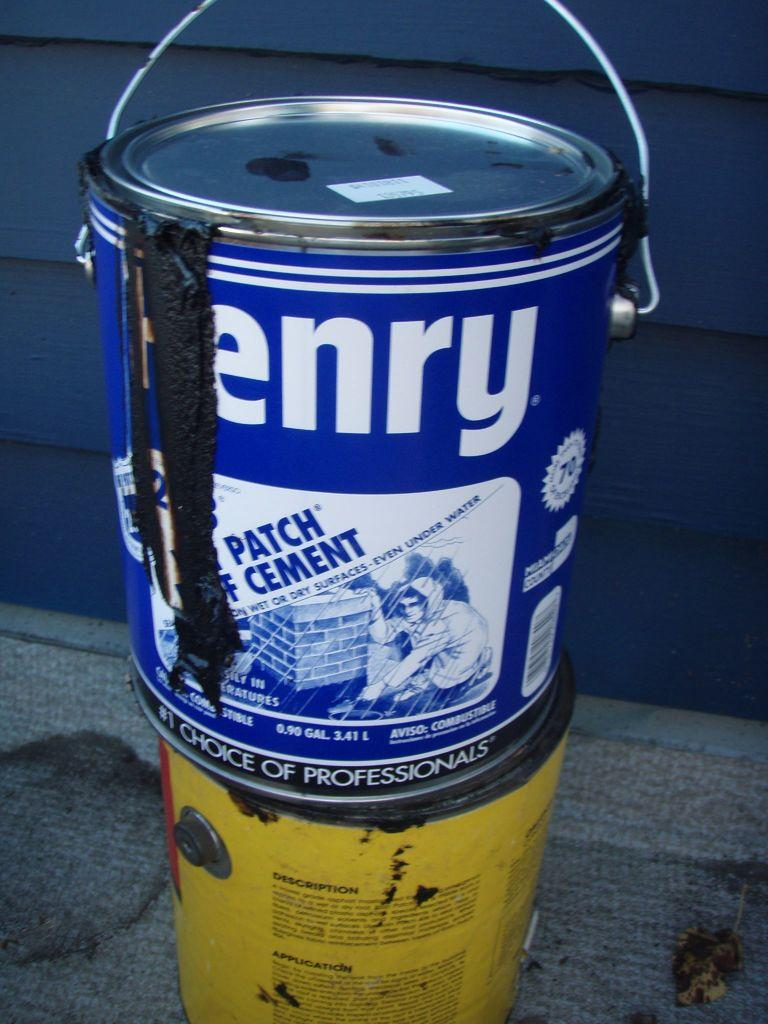<image>
Present a compact description of the photo's key features. Cement oozed from the left side of the gallon of Henry. 